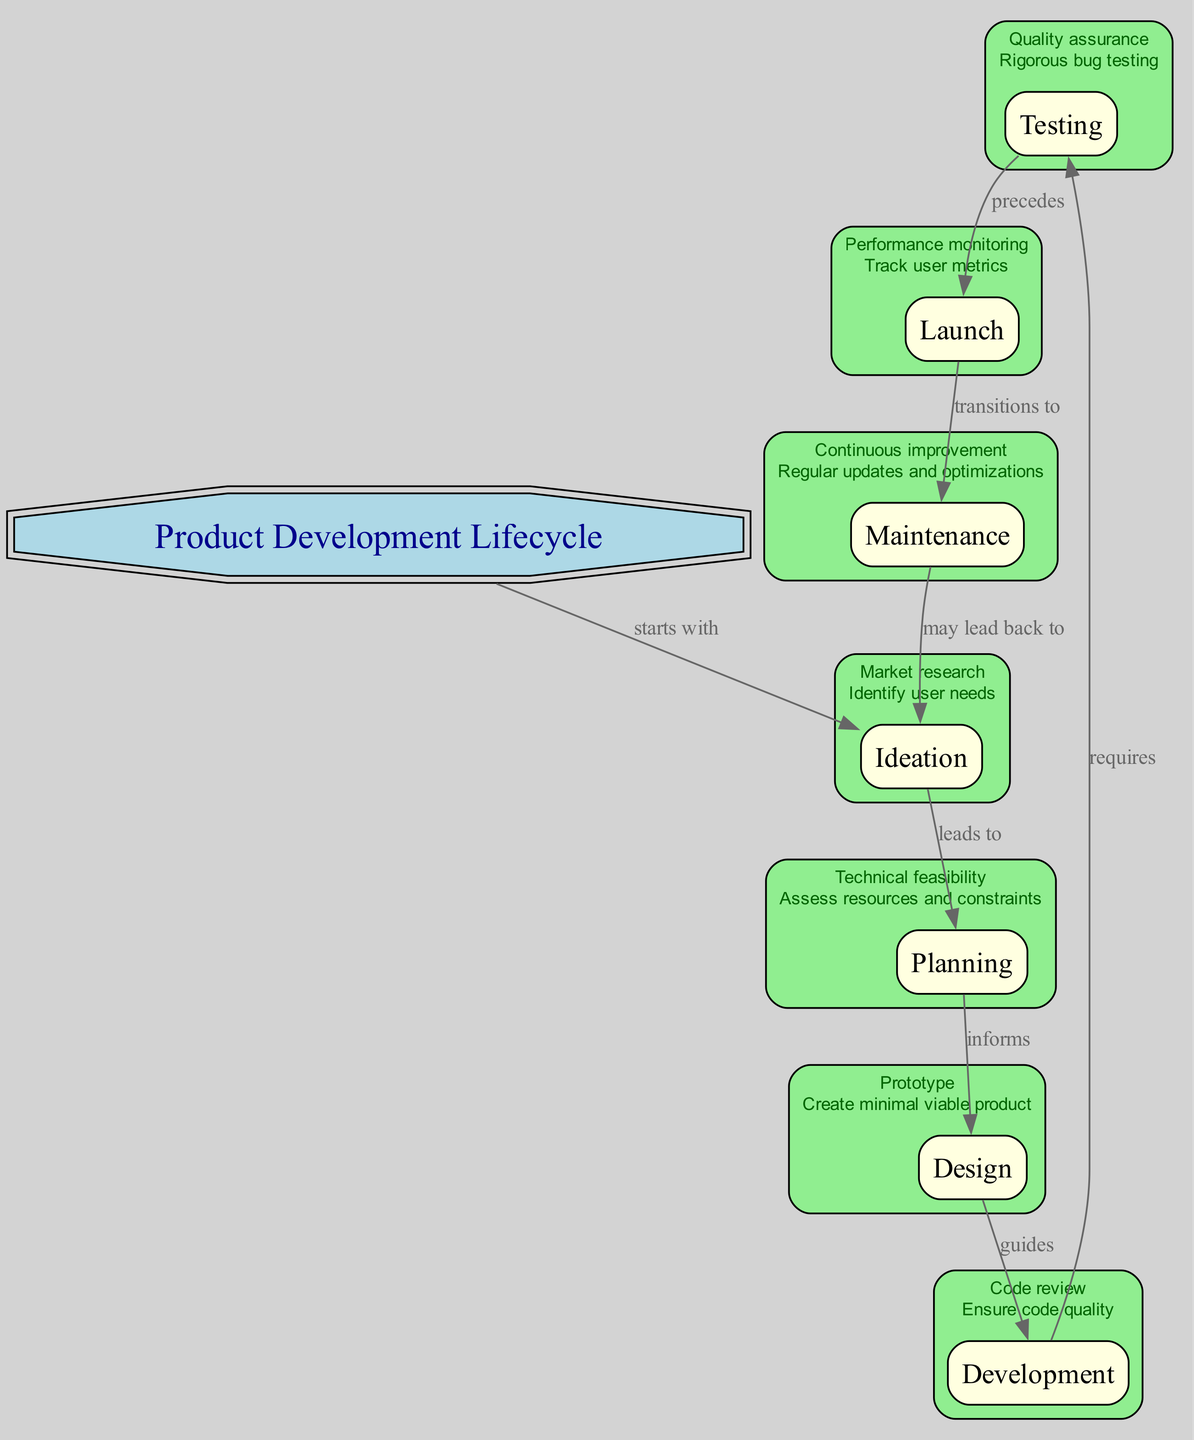What is the starting stage of the Product Development Lifecycle? The diagram indicates that the Product Development Lifecycle starts with the "Ideation" stage. This is established through the edge labeled "starts with" connecting "Product Development Lifecycle" to "Ideation".
Answer: Ideation What milestone follows Design in the lifecycle? According to the diagram, the milestone that follows Design is Development, as indicated by the edge labeled "guides" leading from "Design" to "Development".
Answer: Development How many stages are there in total? By counting the nodes listed in the diagram, there are eight stages in total: Ideation, Planning, Design, Development, Testing, Launch, Maintenance, and the Product Development Lifecycle node itself. Thus, there are seven stages of product development.
Answer: 7 What does Quality Assurance in Testing involve? The diagram specifies that "Quality assurance" in Testing corresponds to "Rigorous bug testing". This is identified through the attribute assigned to the Testing node.
Answer: Rigorous bug testing What is the relationship between Testing and Launch? In the diagram, the relationship between Testing and Launch is defined by the edge labeled "precedes". This indicates that Testing comes before Launch in the lifecycle.
Answer: Precedes Which stage includes Performance Monitoring as an attribute? The stage that includes Performance Monitoring is Launch, as indicated in the diagram where the attribute for the Launch node reads "Performance monitoring" with the accompanying description "Track user metrics".
Answer: Launch What could Maintenance potentially lead back to? The diagram shows that Maintenance may lead back to Ideation, as indicated by the edge labeled "may lead back to" connecting Maintenance to Ideation.
Answer: Ideation What guides the Development stage? The diagram states that the Development stage is guided by the Design stage, as evidenced by the edge labeled "guides" which connects "Design" to "Development".
Answer: Design 